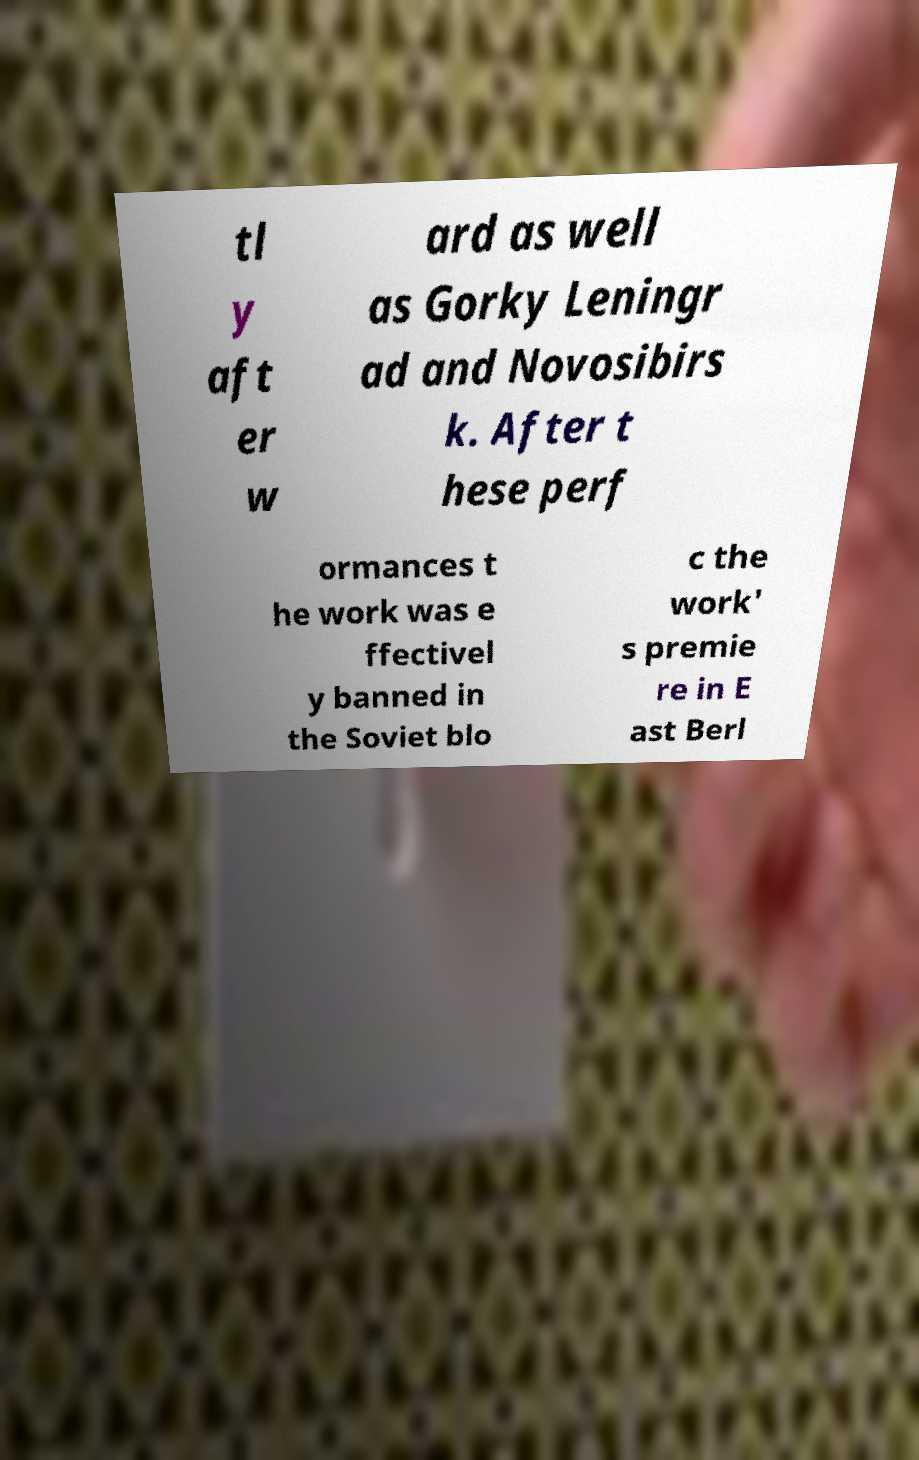Could you assist in decoding the text presented in this image and type it out clearly? tl y aft er w ard as well as Gorky Leningr ad and Novosibirs k. After t hese perf ormances t he work was e ffectivel y banned in the Soviet blo c the work' s premie re in E ast Berl 